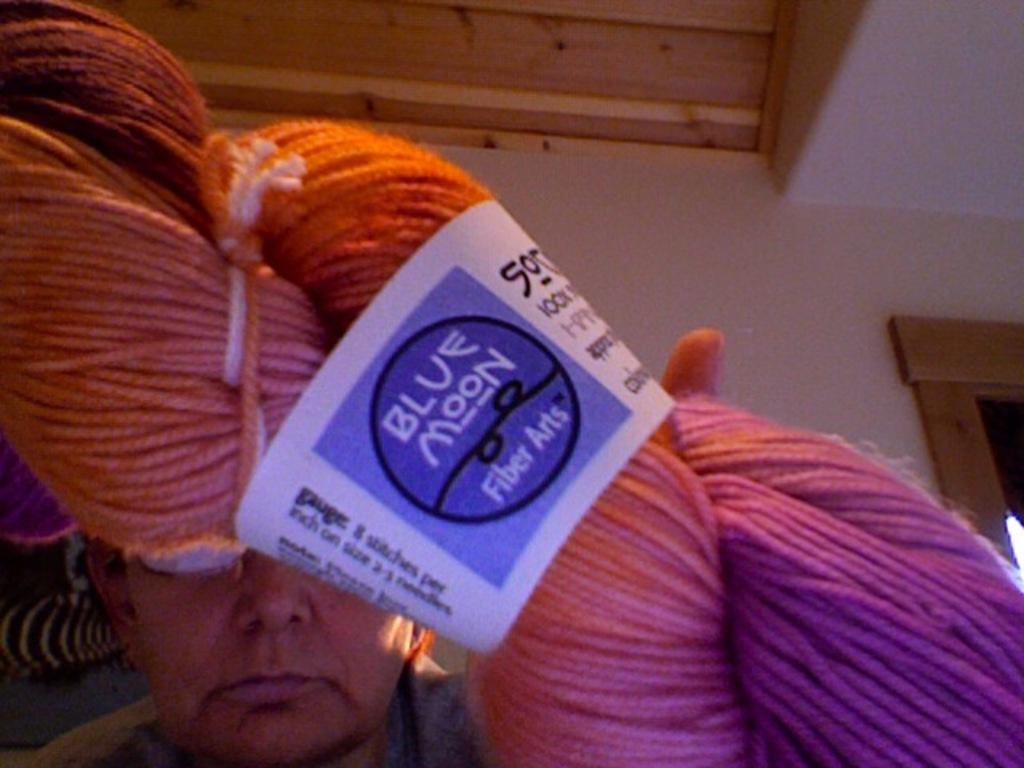What is the person in the center of the image holding? The person in the center of the image is holding wool. What can be seen in the background of the image? There is a wall, a window, and a board visible in the background of the image. What is the structure of the roof visible at the top of the image? The roof is visible at the top of the image, but its structure cannot be determined from the image. What type of business is being conducted in the room in the image? There is no room present in the image, and therefore no business can be conducted within it. 